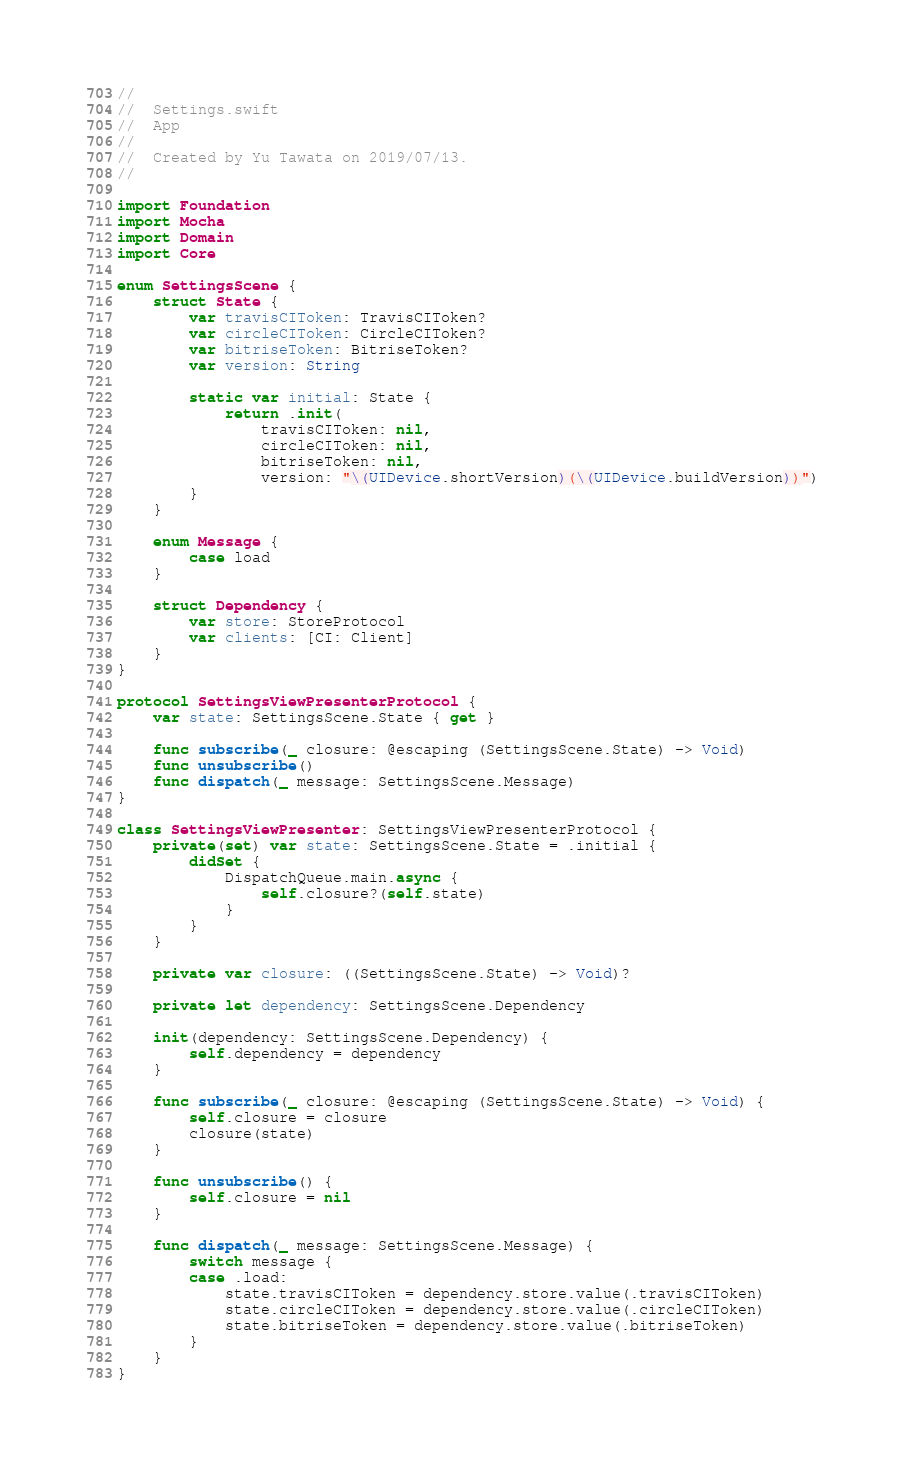<code> <loc_0><loc_0><loc_500><loc_500><_Swift_>//
//  Settings.swift
//  App
//
//  Created by Yu Tawata on 2019/07/13.
//

import Foundation
import Mocha
import Domain
import Core

enum SettingsScene {
    struct State {
        var travisCIToken: TravisCIToken?
        var circleCIToken: CircleCIToken?
        var bitriseToken: BitriseToken?
        var version: String

        static var initial: State {
            return .init(
                travisCIToken: nil,
                circleCIToken: nil,
                bitriseToken: nil,
                version: "\(UIDevice.shortVersion)(\(UIDevice.buildVersion))")
        }
    }

    enum Message {
        case load
    }

    struct Dependency {
        var store: StoreProtocol
        var clients: [CI: Client]
    }
}

protocol SettingsViewPresenterProtocol {
    var state: SettingsScene.State { get }

    func subscribe(_ closure: @escaping (SettingsScene.State) -> Void)
    func unsubscribe()
    func dispatch(_ message: SettingsScene.Message)
}

class SettingsViewPresenter: SettingsViewPresenterProtocol {
    private(set) var state: SettingsScene.State = .initial {
        didSet {
            DispatchQueue.main.async {
                self.closure?(self.state)
            }
        }
    }

    private var closure: ((SettingsScene.State) -> Void)?

    private let dependency: SettingsScene.Dependency

    init(dependency: SettingsScene.Dependency) {
        self.dependency = dependency
    }

    func subscribe(_ closure: @escaping (SettingsScene.State) -> Void) {
        self.closure = closure
        closure(state)
    }

    func unsubscribe() {
        self.closure = nil
    }

    func dispatch(_ message: SettingsScene.Message) {
        switch message {
        case .load:
            state.travisCIToken = dependency.store.value(.travisCIToken)
            state.circleCIToken = dependency.store.value(.circleCIToken)
            state.bitriseToken = dependency.store.value(.bitriseToken)
        }
    }
}
</code> 